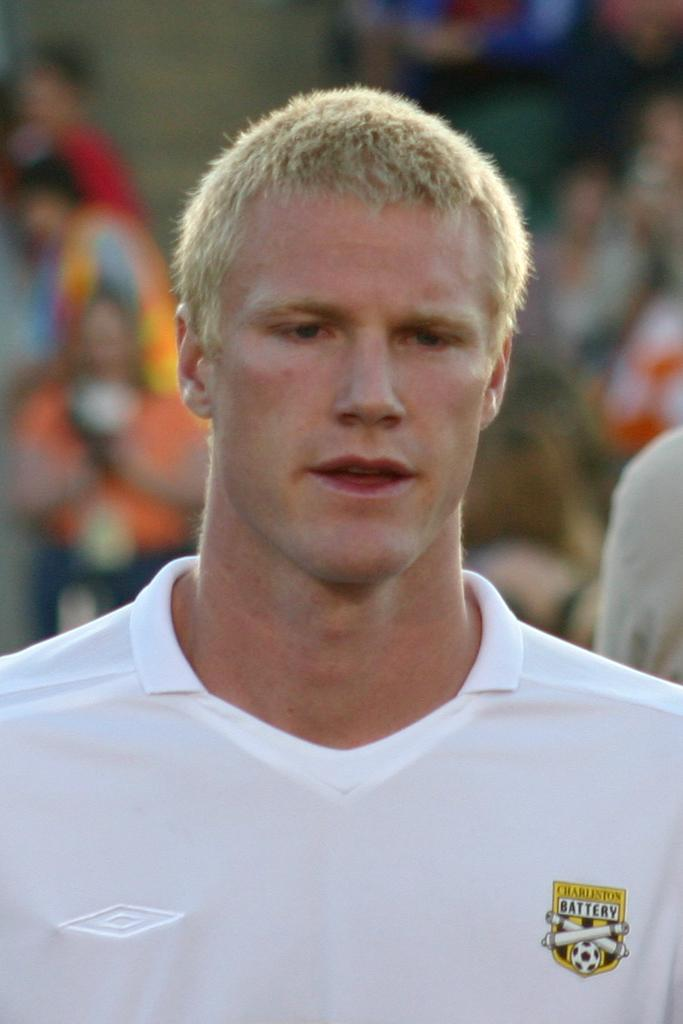<image>
Share a concise interpretation of the image provided. A man wears a shirt with Charleston Battery on the front. 